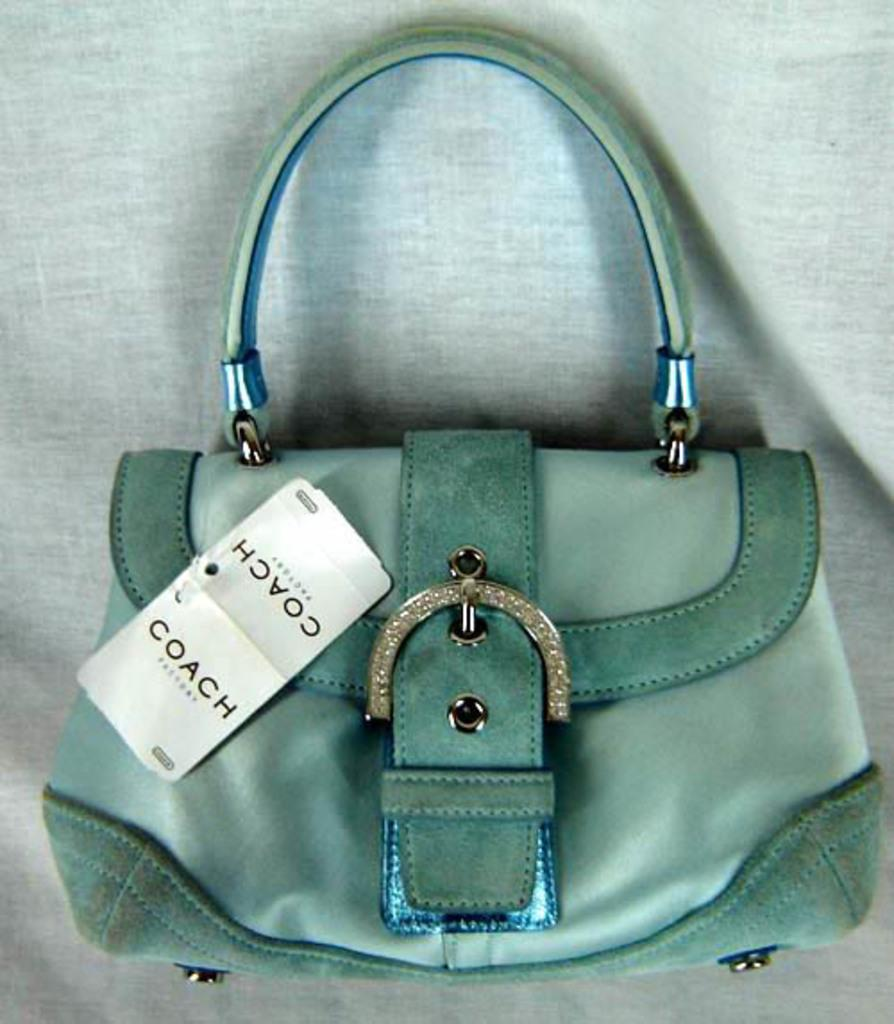What color is the bag in the picture? The bag in the picture is green. Does the bag have any identifying features? Yes, the bag has a tag that says "coach." What type of structure is attached to the bag? The bag has a belt-like structure. How can the bag be carried? The bag has a handle for carrying. What is the background color behind the bag? The background behind the bag is white. Can you hear the bag laughing in the image? There is no sound or laughter associated with the bag in the image; it is a still image of a green bag with a tag and other features. 